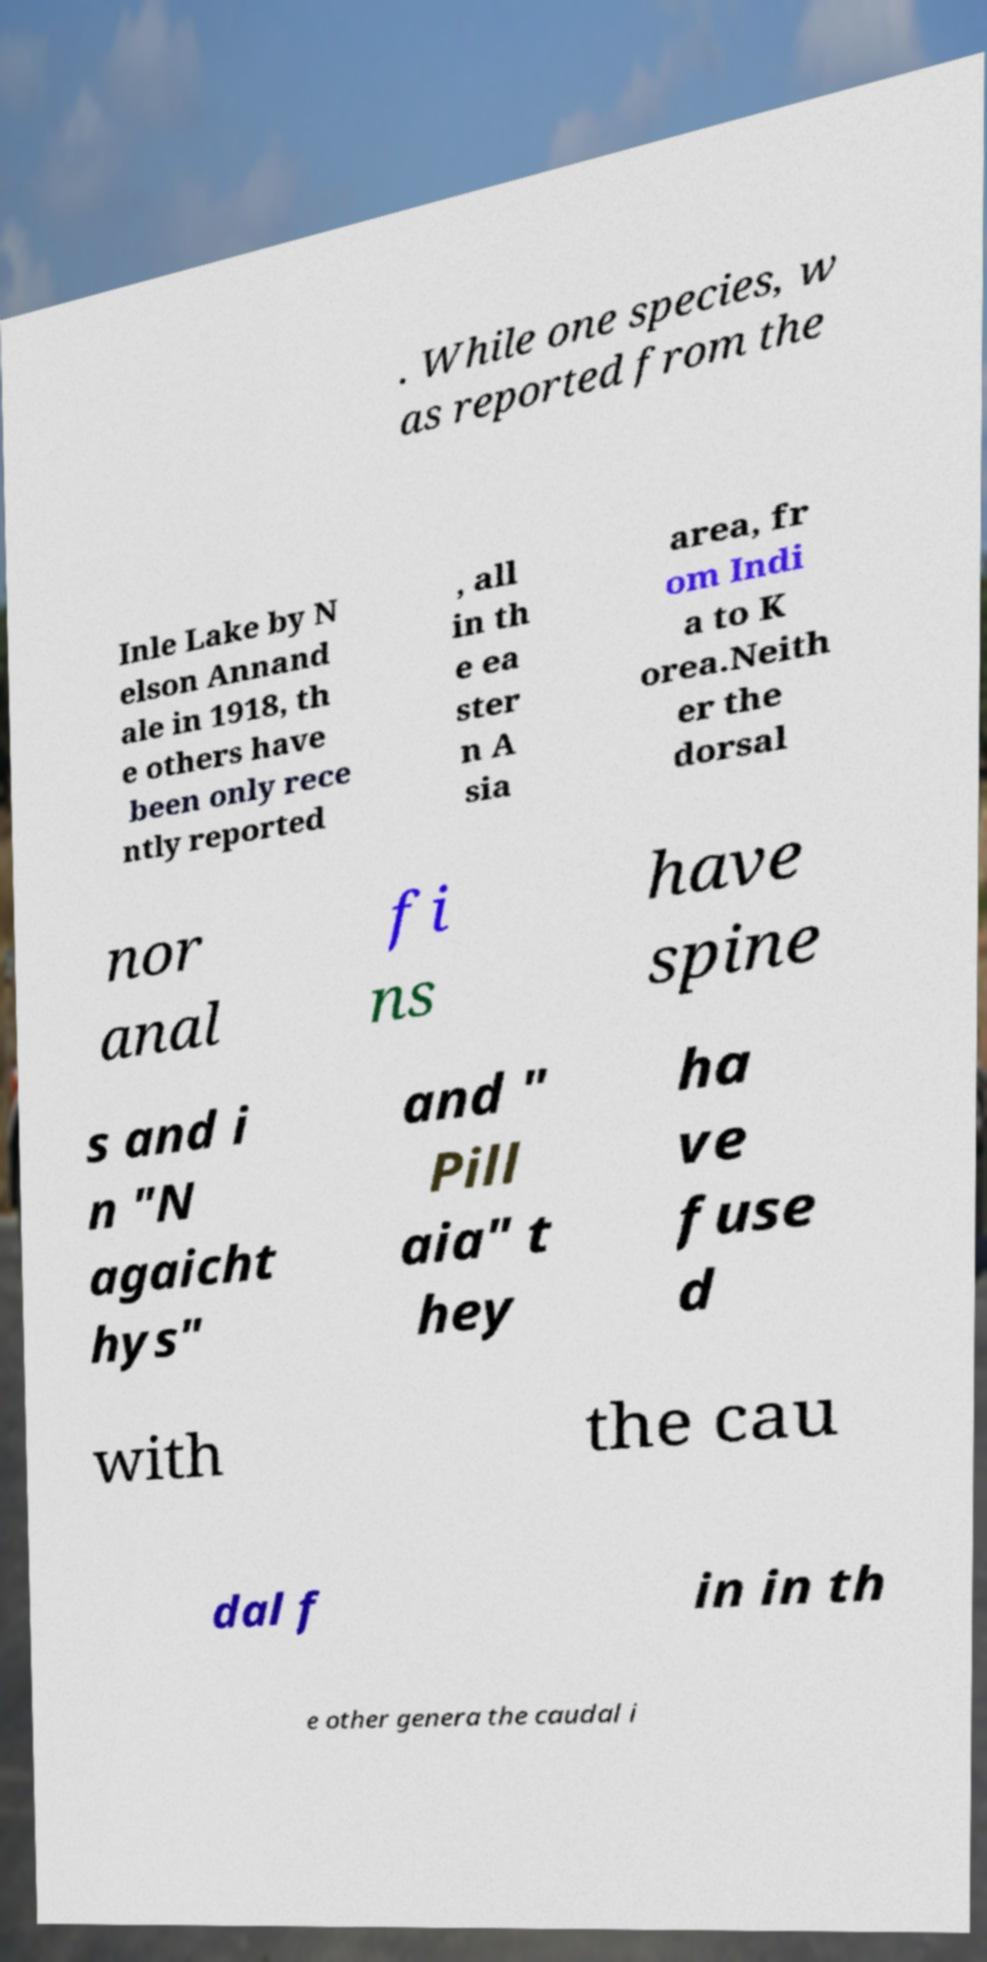I need the written content from this picture converted into text. Can you do that? . While one species, w as reported from the Inle Lake by N elson Annand ale in 1918, th e others have been only rece ntly reported , all in th e ea ster n A sia area, fr om Indi a to K orea.Neith er the dorsal nor anal fi ns have spine s and i n "N agaicht hys" and " Pill aia" t hey ha ve fuse d with the cau dal f in in th e other genera the caudal i 